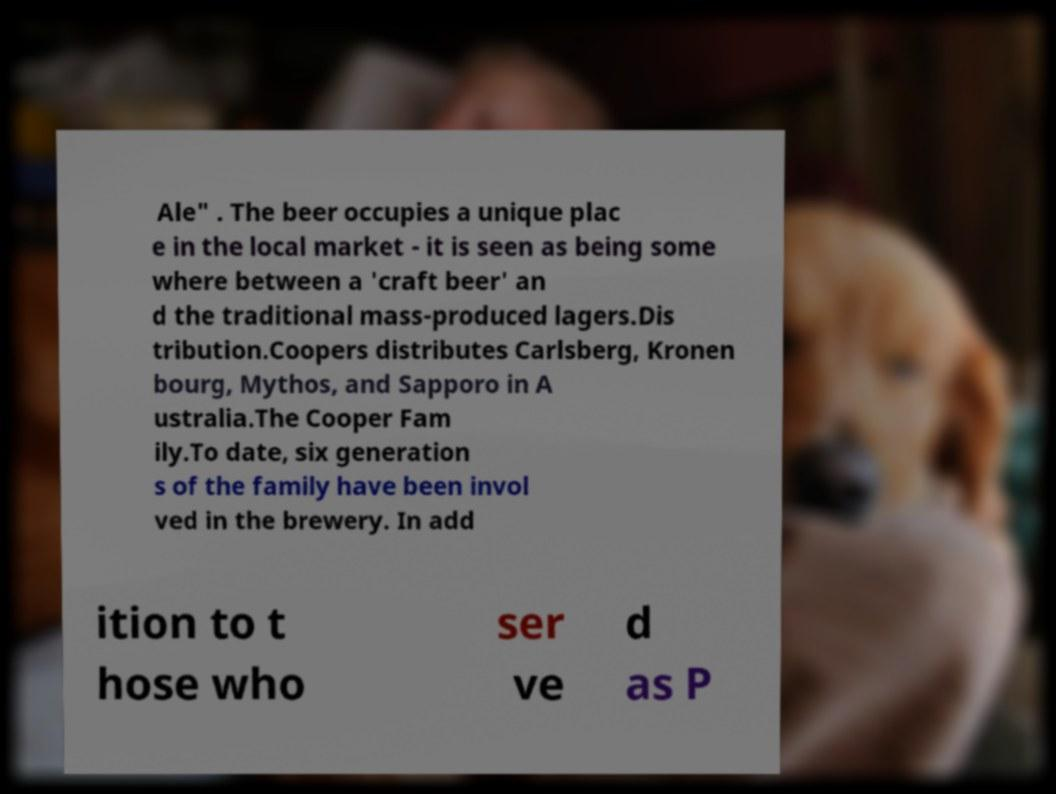Can you accurately transcribe the text from the provided image for me? Ale" . The beer occupies a unique plac e in the local market - it is seen as being some where between a 'craft beer' an d the traditional mass-produced lagers.Dis tribution.Coopers distributes Carlsberg, Kronen bourg, Mythos, and Sapporo in A ustralia.The Cooper Fam ily.To date, six generation s of the family have been invol ved in the brewery. In add ition to t hose who ser ve d as P 